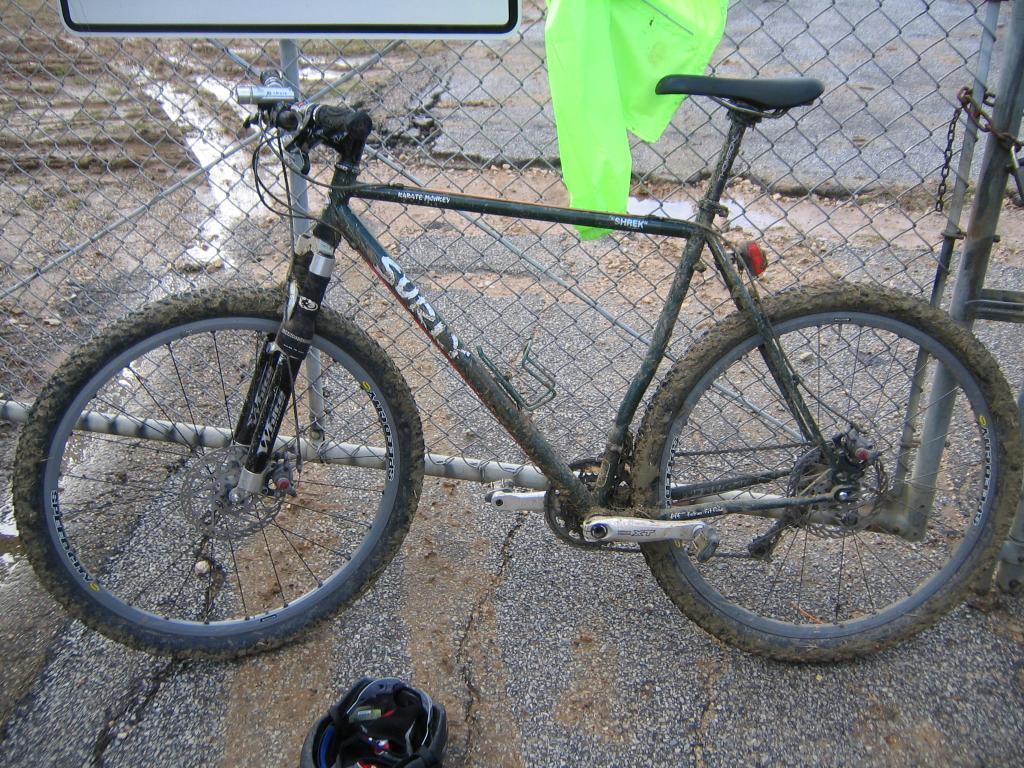Could you give a brief overview of what you see in this image? In this image, we can see a bicycle. Behind the bicycle, there is a mesh, poles, board, some cloth we can see here. Right side of the image, we can see a chain. At the bottom, there is a helmet on the ground. 